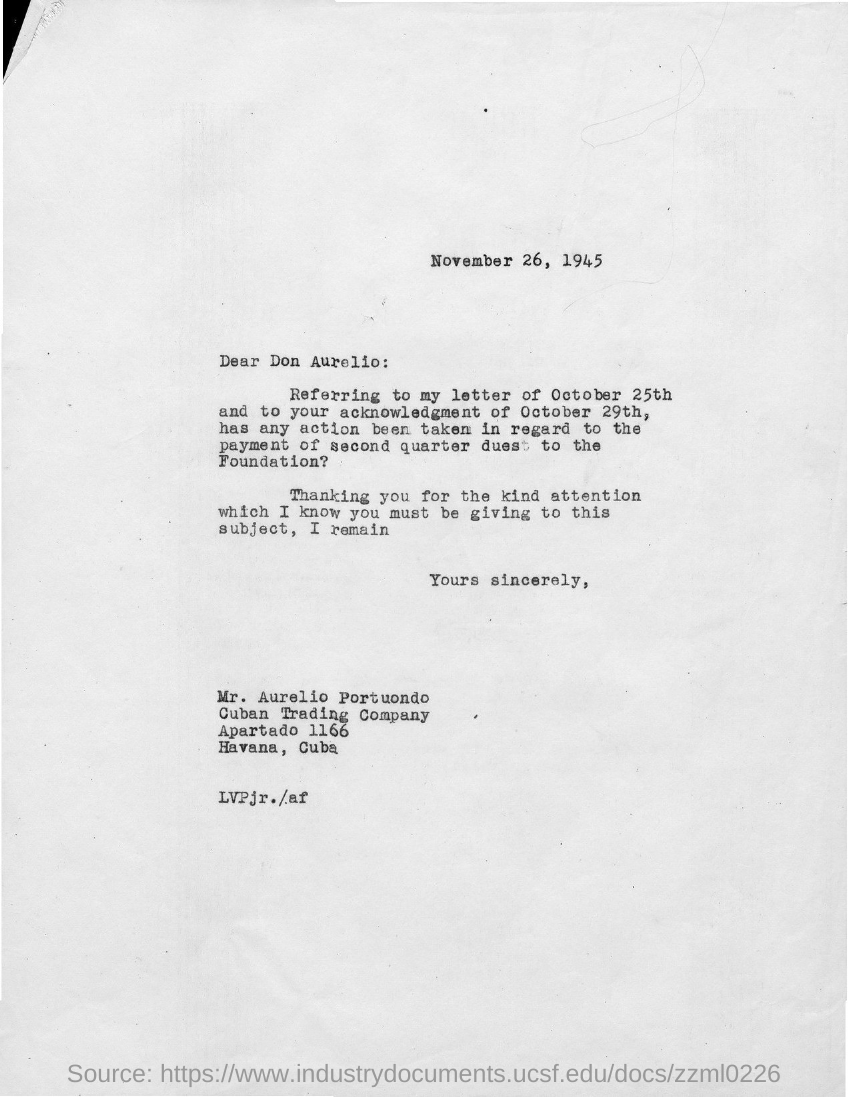Outline some significant characteristics in this image. The letter is dated November 26, 1945. To whom is this letter addressed? The street address of Cuban Trading Company is Apartado 1166. 